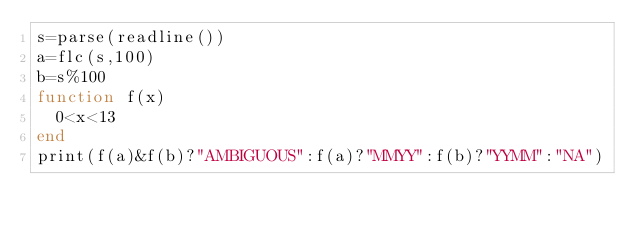<code> <loc_0><loc_0><loc_500><loc_500><_Julia_>s=parse(readline())
a=flc(s,100)
b=s%100
function f(x)
  0<x<13
end
print(f(a)&f(b)?"AMBIGUOUS":f(a)?"MMYY":f(b)?"YYMM":"NA")</code> 